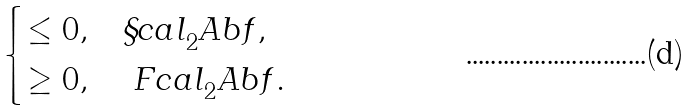<formula> <loc_0><loc_0><loc_500><loc_500>\begin{cases} \leq 0 , & \S c a l _ { 2 } ^ { \ } A b f , \\ \geq 0 , & \ F c a l _ { 2 } ^ { \ } A b f . \end{cases}</formula> 